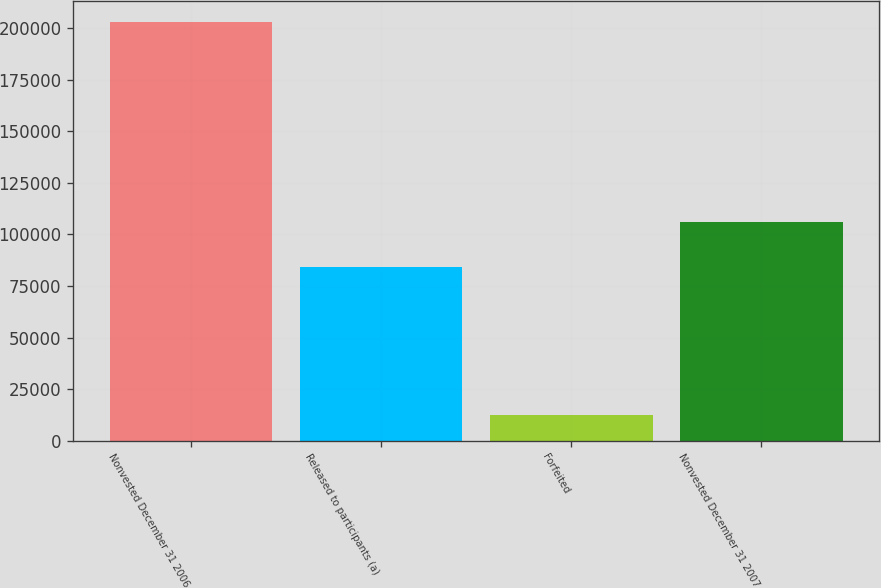<chart> <loc_0><loc_0><loc_500><loc_500><bar_chart><fcel>Nonvested December 31 2006<fcel>Released to participants (a)<fcel>Forfeited<fcel>Nonvested December 31 2007<nl><fcel>202885<fcel>84418<fcel>12328<fcel>106139<nl></chart> 